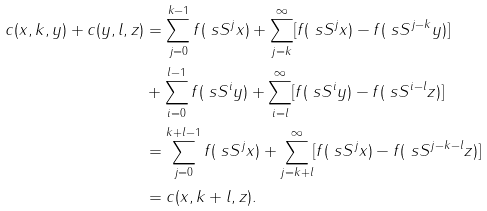<formula> <loc_0><loc_0><loc_500><loc_500>c ( x , k , y ) + c ( y , l , z ) & = \sum _ { j = 0 } ^ { k - 1 } f ( \ s S ^ { j } x ) + \sum _ { j = k } ^ { \infty } [ f ( \ s S ^ { j } x ) - f ( \ s S ^ { j - k } y ) ] \\ & + \sum _ { i = 0 } ^ { l - 1 } f ( \ s S ^ { i } y ) + \sum _ { i = l } ^ { \infty } [ f ( \ s S ^ { i } y ) - f ( \ s S ^ { i - l } z ) ] \\ & = \sum _ { j = 0 } ^ { k + l - 1 } f ( \ s S ^ { j } x ) + \sum _ { j = k + l } ^ { \infty } [ f ( \ s S ^ { j } x ) - f ( \ s S ^ { j - k - l } z ) ] \\ & = c ( x , k + l , z ) .</formula> 